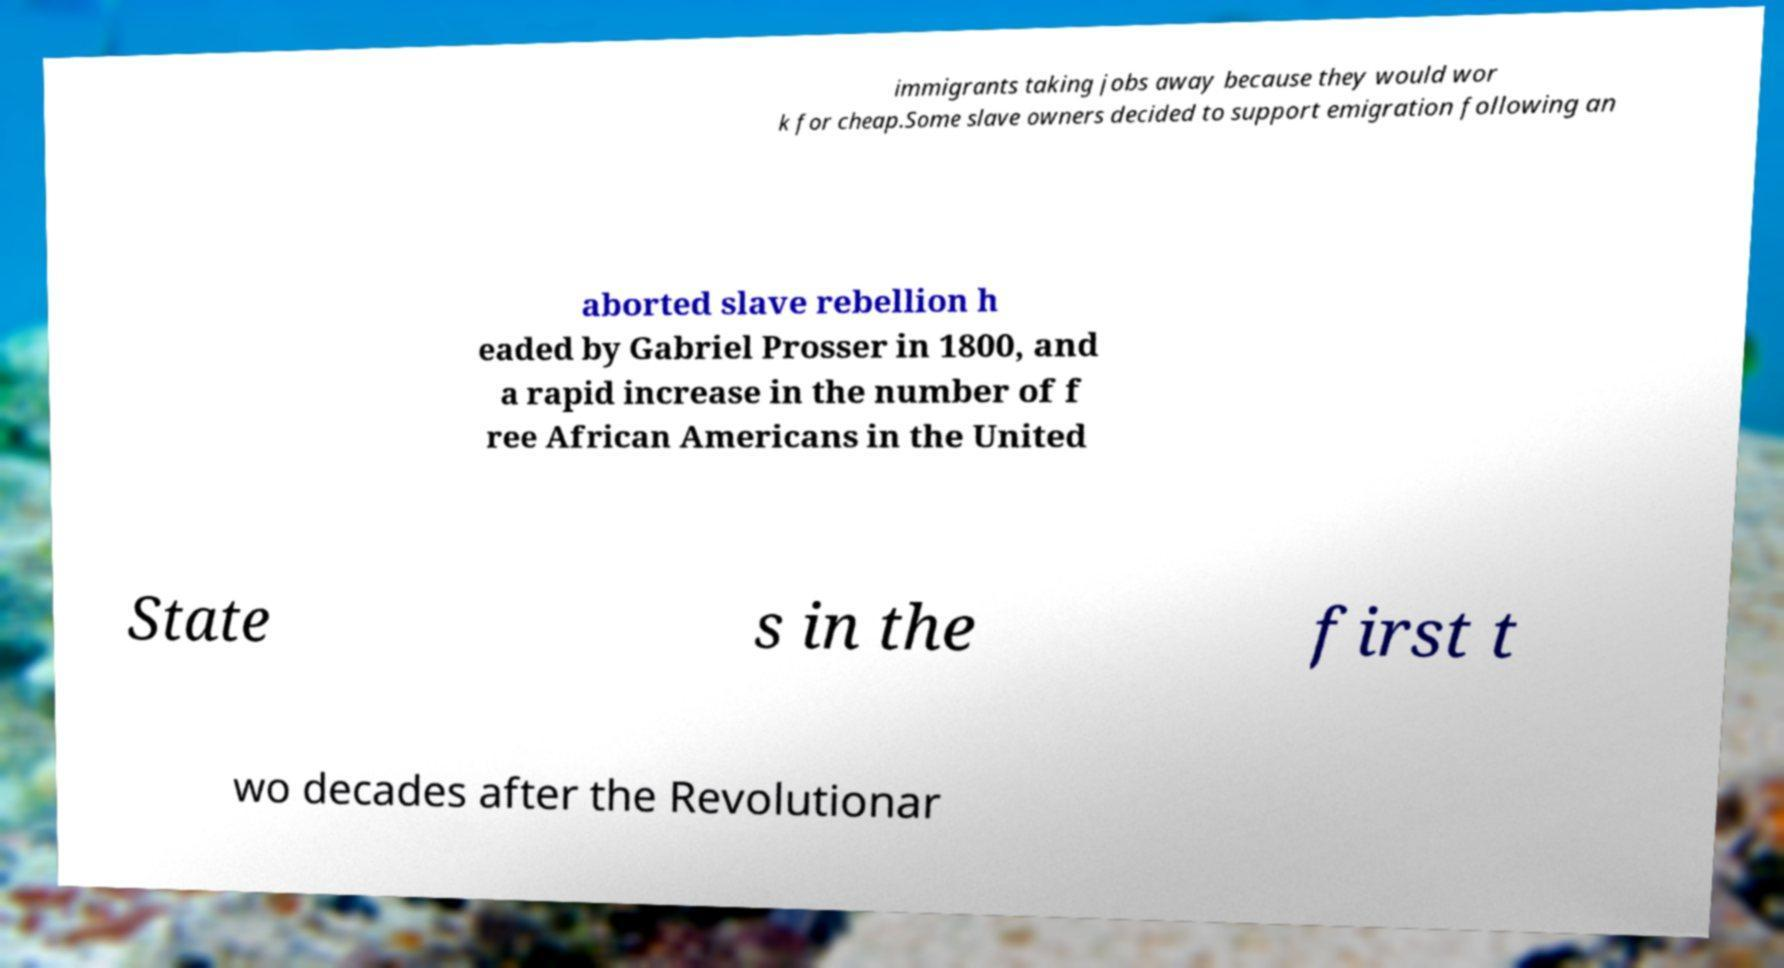Can you read and provide the text displayed in the image?This photo seems to have some interesting text. Can you extract and type it out for me? immigrants taking jobs away because they would wor k for cheap.Some slave owners decided to support emigration following an aborted slave rebellion h eaded by Gabriel Prosser in 1800, and a rapid increase in the number of f ree African Americans in the United State s in the first t wo decades after the Revolutionar 